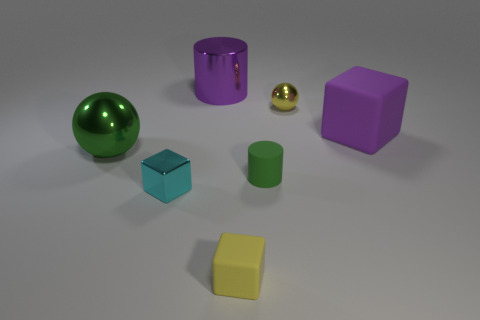Add 1 tiny blue cubes. How many objects exist? 8 Subtract all small blocks. How many blocks are left? 1 Subtract all green balls. How many balls are left? 1 Subtract 1 balls. How many balls are left? 1 Subtract all cubes. How many objects are left? 4 Subtract 0 red spheres. How many objects are left? 7 Subtract all gray blocks. Subtract all cyan cylinders. How many blocks are left? 3 Subtract all gray cubes. How many green cylinders are left? 1 Subtract all small blue metal objects. Subtract all green rubber cylinders. How many objects are left? 6 Add 6 large purple cylinders. How many large purple cylinders are left? 7 